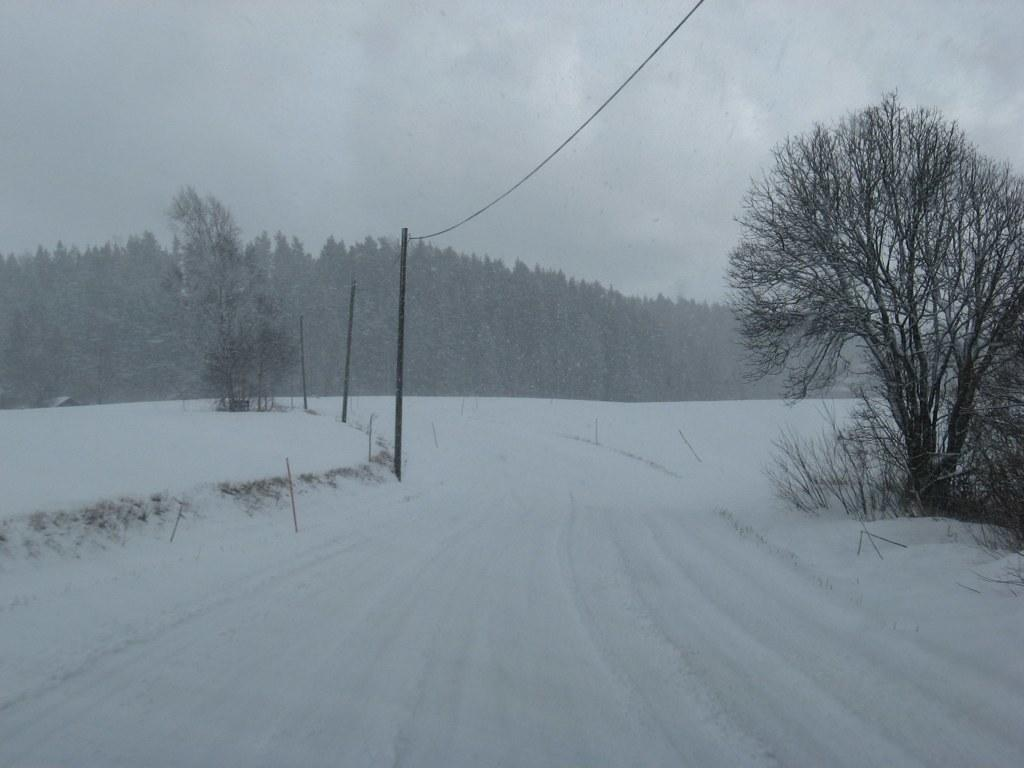What objects are on the snow in the image? There are poles on the snow in the image. Where is the tree located in the image? The tree is in the right corner of the image. What can be seen in the background of the image? There are trees covered with snow in the background of the image. What type of orange can be seen hanging from the tree in the image? There is no orange present in the image; the tree is covered with snow. 